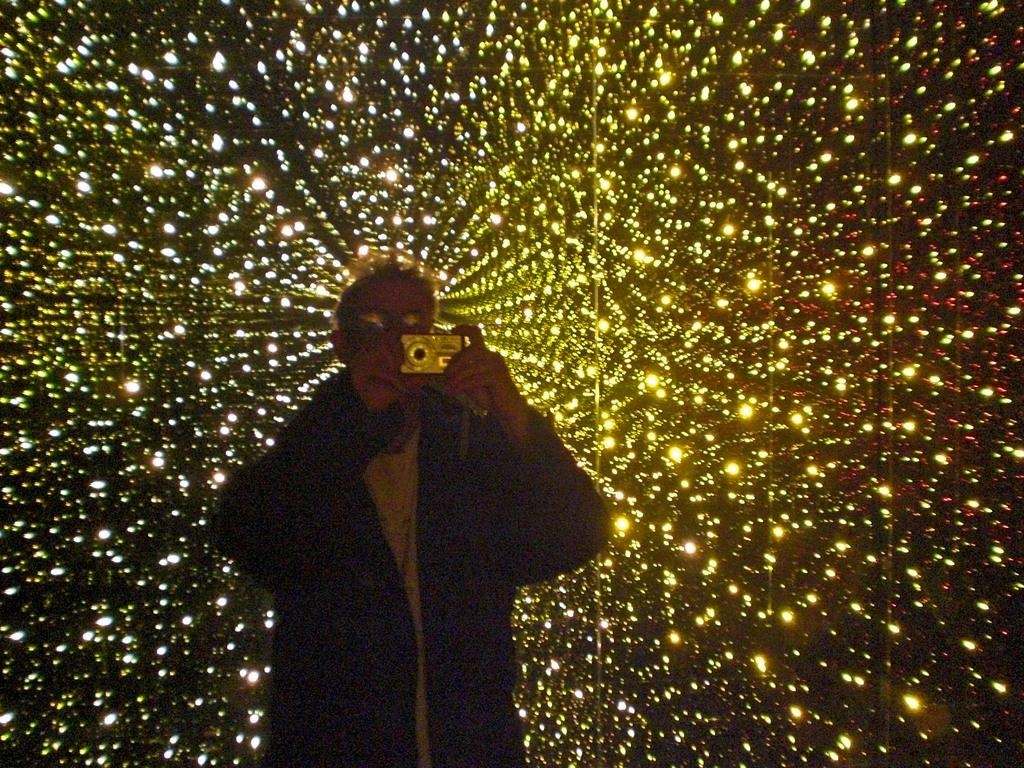Who is present in the image? There is a person in the image. What is the person holding in the image? The person is holding a camera. What can be seen in the background of the image? There are lights visible in the background of the image. What type of alarm is the person trying to disarm in the image? There is no alarm present in the image; the person is holding a camera. Can you see a kitty playing with the lights in the background of the image? There is no kitty present in the image; only lights are visible in the background. 